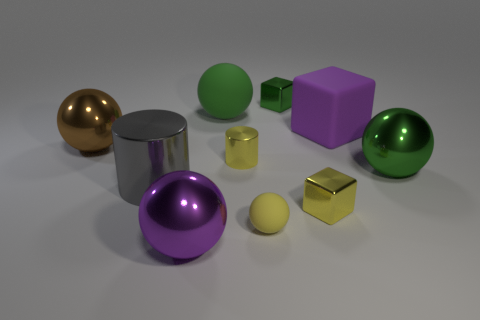Is the color of the cylinder on the right side of the big gray metallic cylinder the same as the tiny matte object?
Offer a very short reply. Yes. Do the gray cylinder and the yellow matte thing have the same size?
Offer a very short reply. No. What shape is the brown object that is the same size as the purple rubber block?
Make the answer very short. Sphere. There is a metal block that is behind the yellow cube; is it the same size as the large brown ball?
Offer a terse response. No. There is another green ball that is the same size as the green shiny sphere; what is it made of?
Give a very brief answer. Rubber. Are there any yellow metallic blocks on the right side of the large object that is behind the purple object right of the purple metallic object?
Provide a succinct answer. Yes. There is a large shiny ball that is on the right side of the small yellow shiny cylinder; is it the same color as the large matte sphere that is behind the purple ball?
Provide a short and direct response. Yes. Is there a gray matte thing?
Provide a short and direct response. No. There is a small cube that is the same color as the large rubber ball; what is it made of?
Your answer should be compact. Metal. What size is the yellow metallic object left of the rubber object that is in front of the green shiny object that is to the right of the purple matte cube?
Your answer should be very brief. Small. 